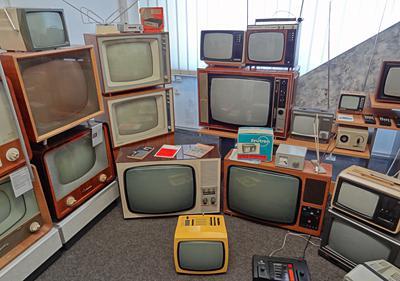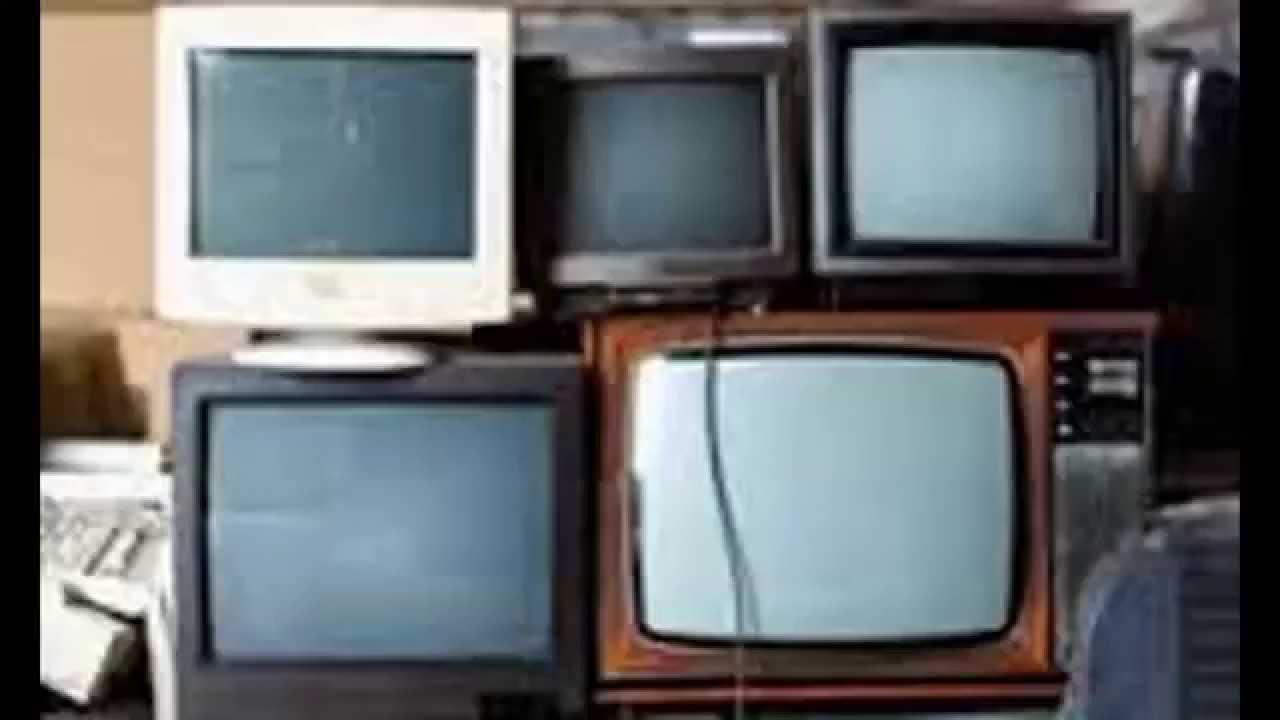The first image is the image on the left, the second image is the image on the right. Considering the images on both sides, is "A stack of old-fashioned TVs includes at least one with a rainbow test pattern and two knobs in a vertical row alongside the screen." valid? Answer yes or no. No. The first image is the image on the left, the second image is the image on the right. Given the left and right images, does the statement "The right image contains exactly five old fashioned television sets." hold true? Answer yes or no. Yes. 